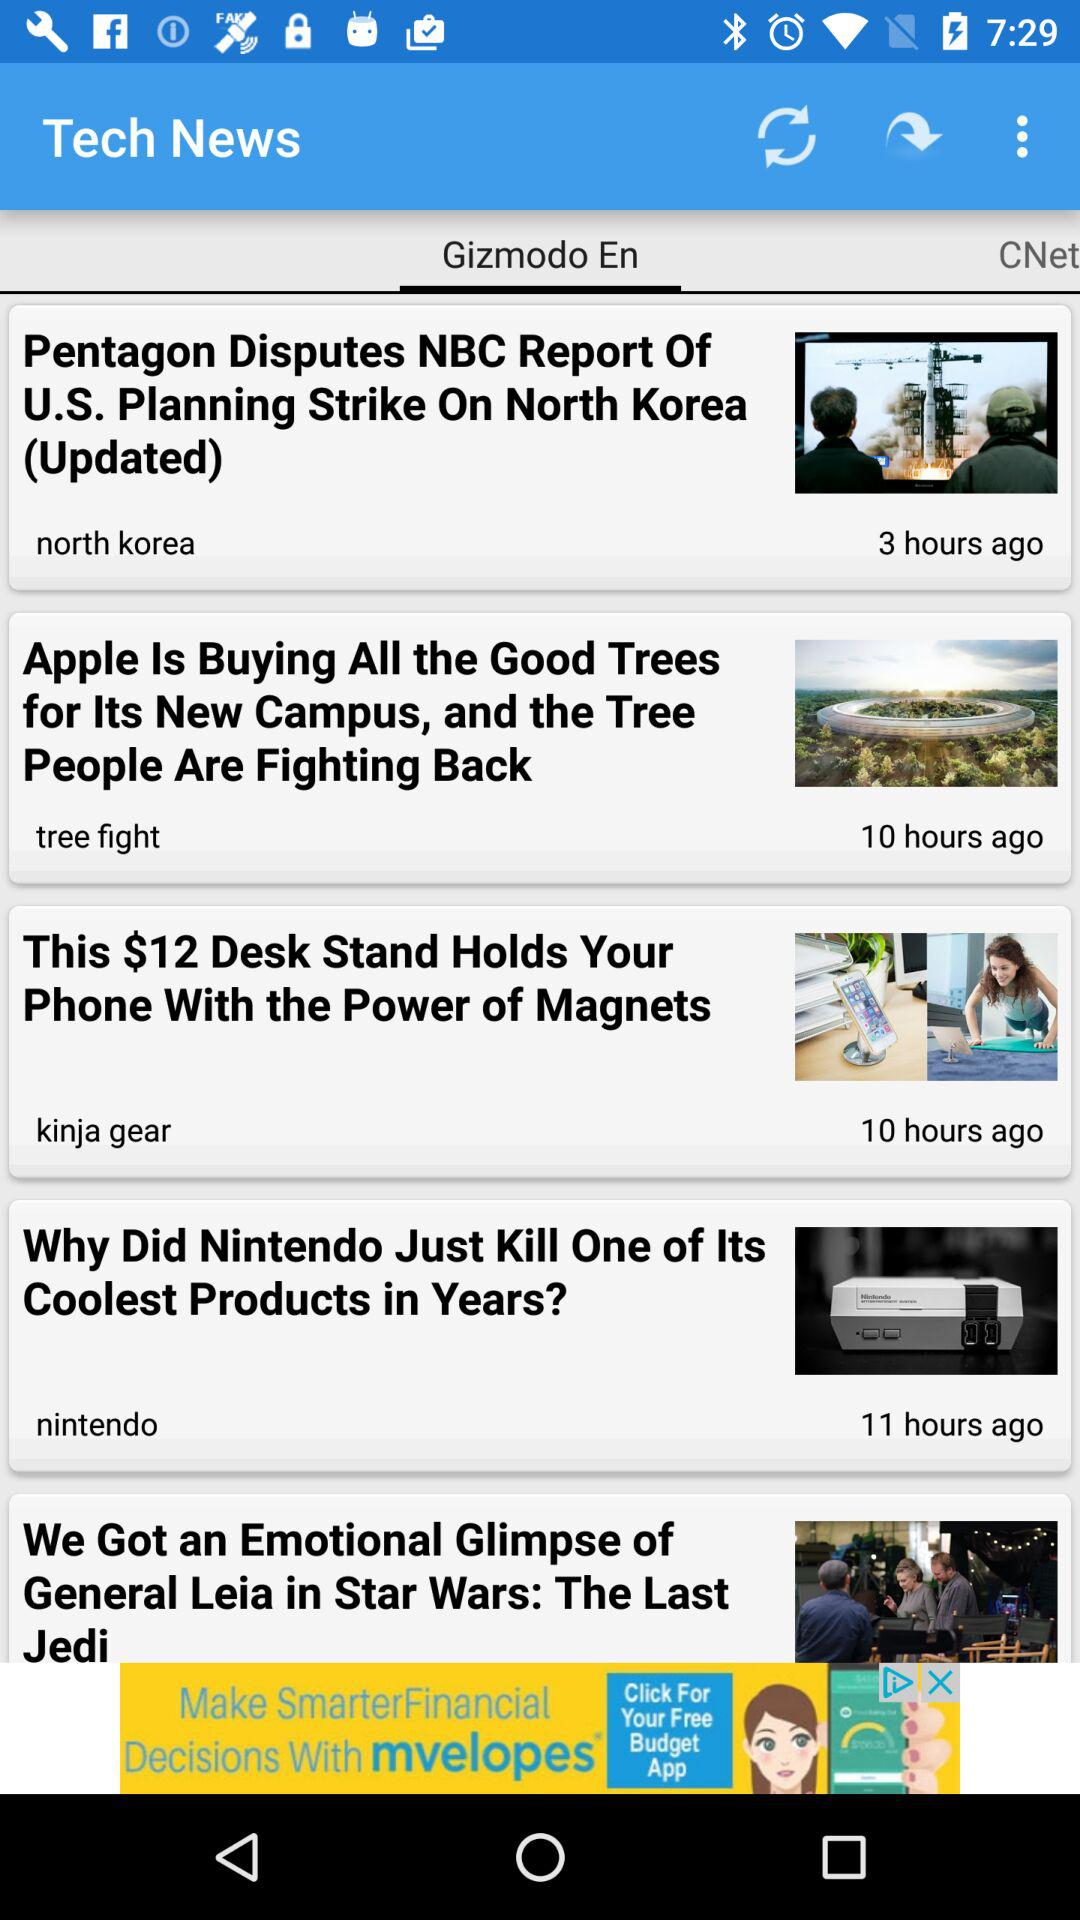How many hours ago was the news posted by "nintendo"? The news was posted by "nintendo" 11 hours ago. 